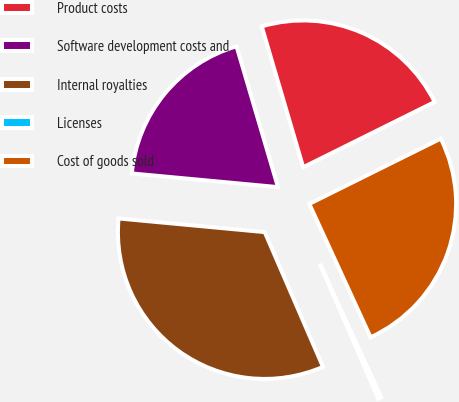Convert chart to OTSL. <chart><loc_0><loc_0><loc_500><loc_500><pie_chart><fcel>Product costs<fcel>Software development costs and<fcel>Internal royalties<fcel>Licenses<fcel>Cost of goods sold<nl><fcel>22.22%<fcel>18.96%<fcel>32.98%<fcel>0.36%<fcel>25.48%<nl></chart> 